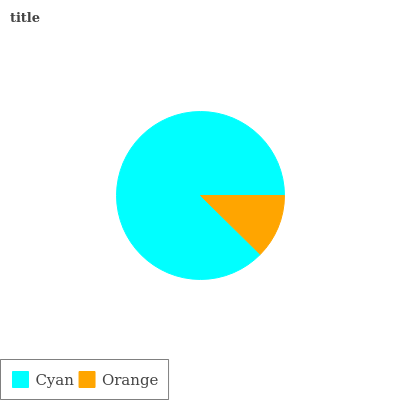Is Orange the minimum?
Answer yes or no. Yes. Is Cyan the maximum?
Answer yes or no. Yes. Is Orange the maximum?
Answer yes or no. No. Is Cyan greater than Orange?
Answer yes or no. Yes. Is Orange less than Cyan?
Answer yes or no. Yes. Is Orange greater than Cyan?
Answer yes or no. No. Is Cyan less than Orange?
Answer yes or no. No. Is Cyan the high median?
Answer yes or no. Yes. Is Orange the low median?
Answer yes or no. Yes. Is Orange the high median?
Answer yes or no. No. Is Cyan the low median?
Answer yes or no. No. 